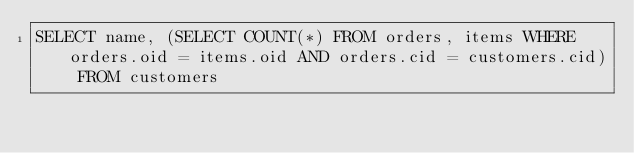Convert code to text. <code><loc_0><loc_0><loc_500><loc_500><_SQL_>SELECT name, (SELECT COUNT(*) FROM orders, items WHERE orders.oid = items.oid AND orders.cid = customers.cid) FROM customers</code> 